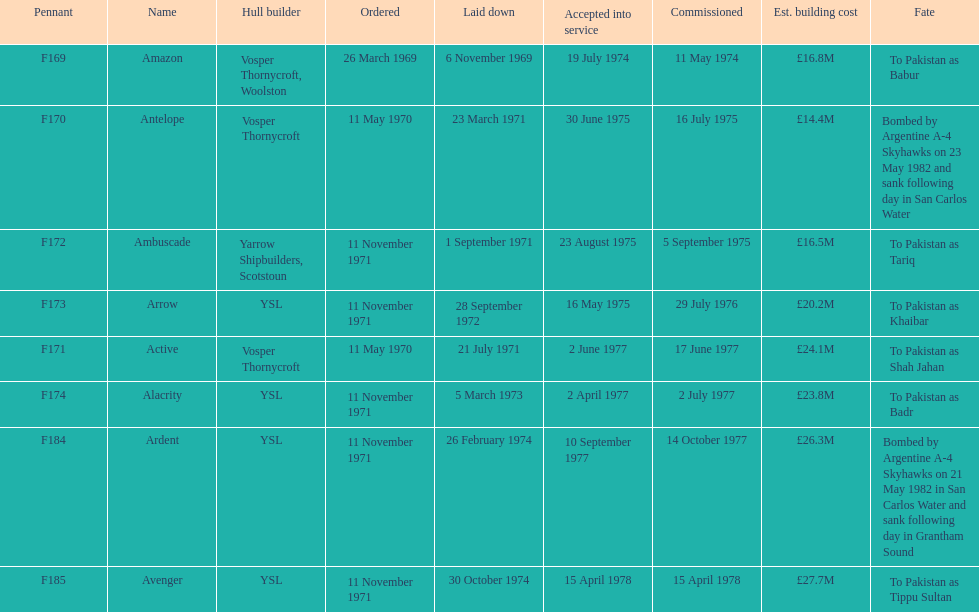How many ships were built after ardent? 1. 